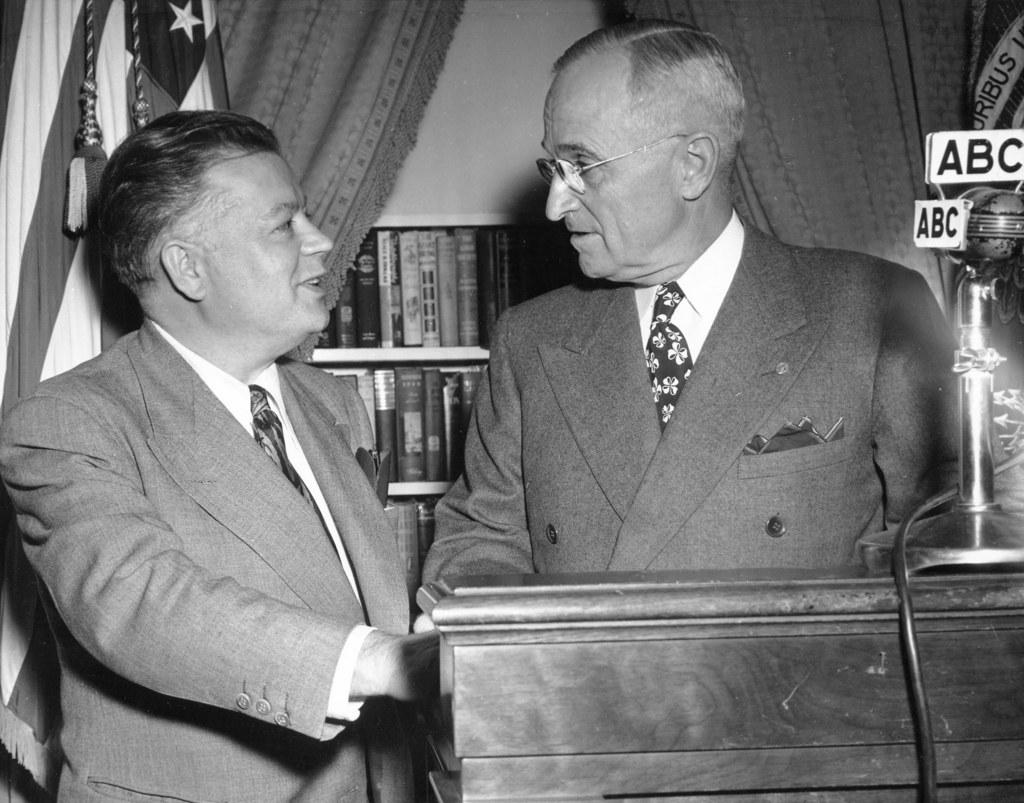<image>
Offer a succinct explanation of the picture presented. Only the ABC network's microphone is visible on the podium where President Harry S. Truman is speaking to another individual. 